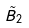<formula> <loc_0><loc_0><loc_500><loc_500>\tilde { B } _ { 2 }</formula> 